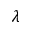<formula> <loc_0><loc_0><loc_500><loc_500>\lambda</formula> 